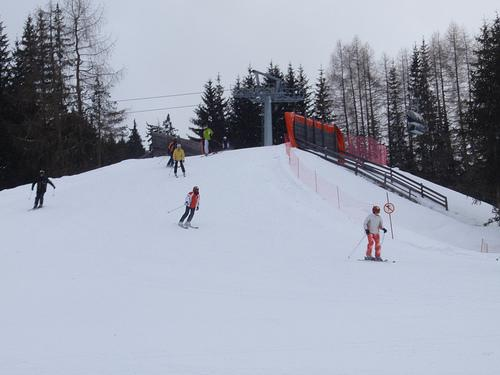Question: who is on the mountain?
Choices:
A. Snowboarders.
B. Skiers.
C. Refugees.
D. Nudists.
Answer with the letter. Answer: B Question: what is above the slope?
Choices:
A. Lift.
B. Trees.
C. Clouds.
D. The moon.
Answer with the letter. Answer: A Question: what shape is the sign to the right?
Choices:
A. Hexagon.
B. Trapezoid.
C. Dodecahedron.
D. Circle.
Answer with the letter. Answer: D Question: why is the sign on the slope?
Choices:
A. Warning skiers.
B. Get business for shake shack.
C. Show how to get to the medical building.
D. Thank skiers for their patronage.
Answer with the letter. Answer: A Question: where is the skier in red pants?
Choices:
A. In back.
B. In front.
C. On the lift.
D. Tumbling down the slope.
Answer with the letter. Answer: B Question: when was this taken?
Choices:
A. During an eclipse.
B. Winter.
C. At sunrise.
D. At New Years.
Answer with the letter. Answer: B 